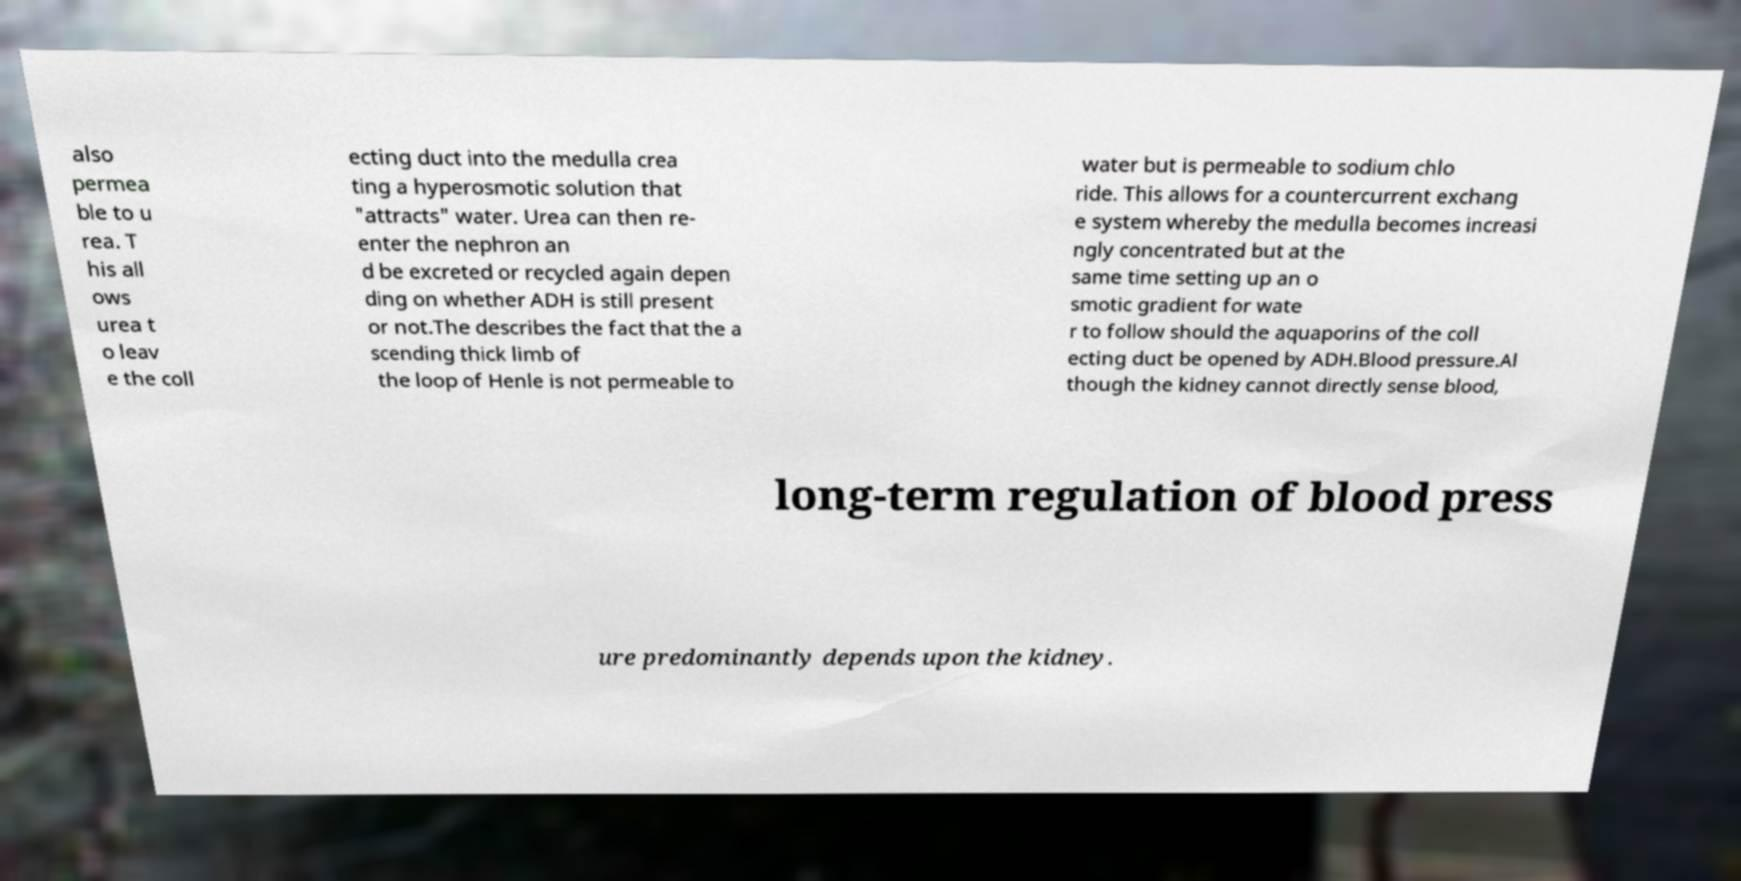For documentation purposes, I need the text within this image transcribed. Could you provide that? also permea ble to u rea. T his all ows urea t o leav e the coll ecting duct into the medulla crea ting a hyperosmotic solution that "attracts" water. Urea can then re- enter the nephron an d be excreted or recycled again depen ding on whether ADH is still present or not.The describes the fact that the a scending thick limb of the loop of Henle is not permeable to water but is permeable to sodium chlo ride. This allows for a countercurrent exchang e system whereby the medulla becomes increasi ngly concentrated but at the same time setting up an o smotic gradient for wate r to follow should the aquaporins of the coll ecting duct be opened by ADH.Blood pressure.Al though the kidney cannot directly sense blood, long-term regulation of blood press ure predominantly depends upon the kidney. 